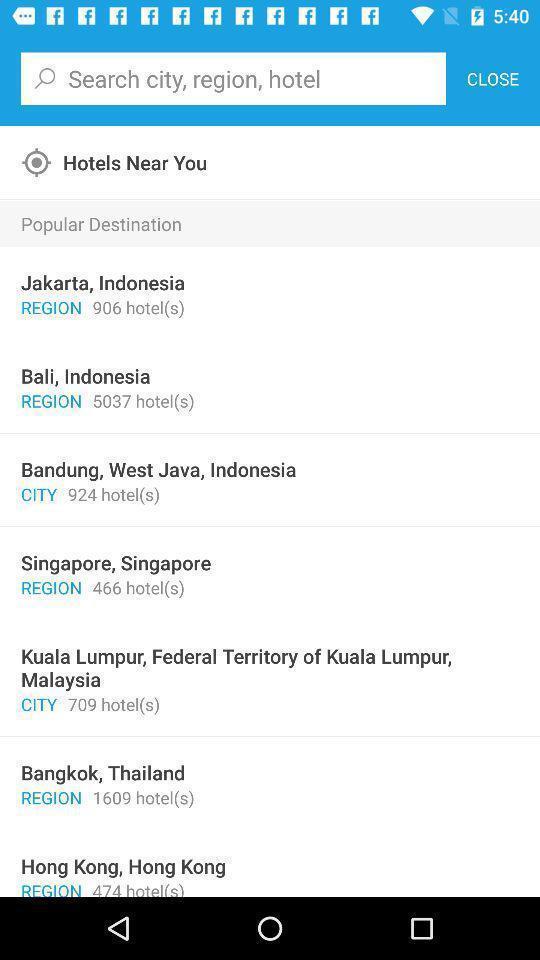Summarize the main components in this picture. Search bar to search city region and hotel. 